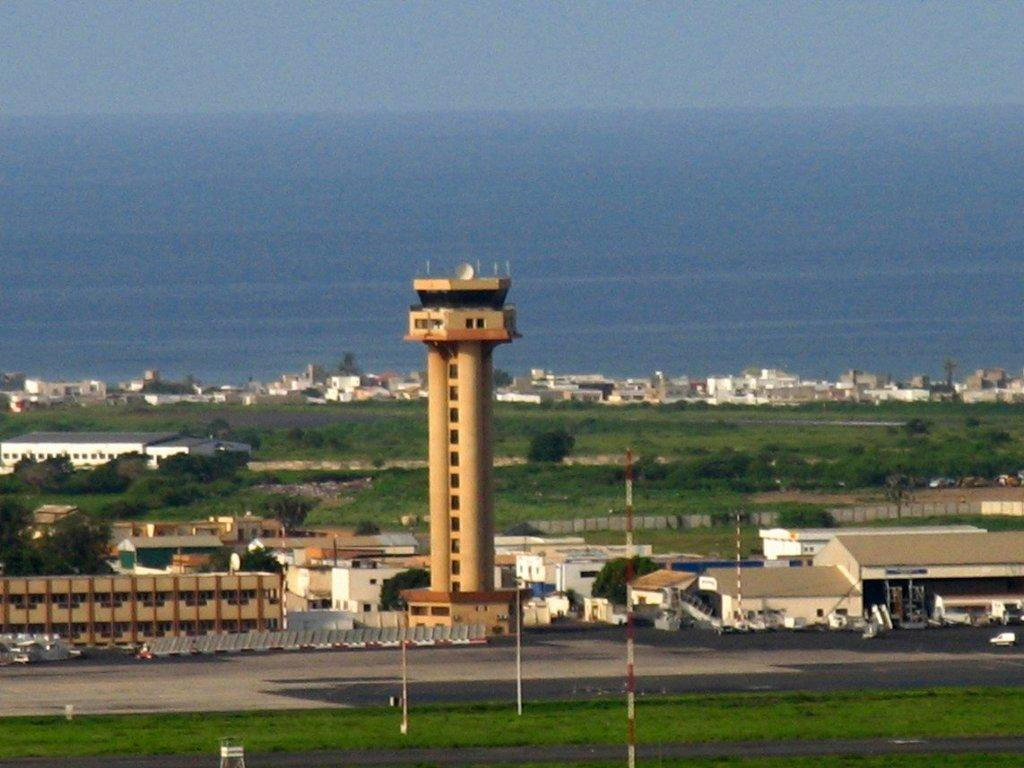What type of landscape is depicted in the image? There is a grassland in the image. What man-made structures can be seen in the image? There are roads, buildings, and a tower in the image. What natural feature is visible in the image? The sea is visible in the image. Where is the kitty playing with a ring made of lace in the image? There is no kitty or ring made of lace present in the image. 